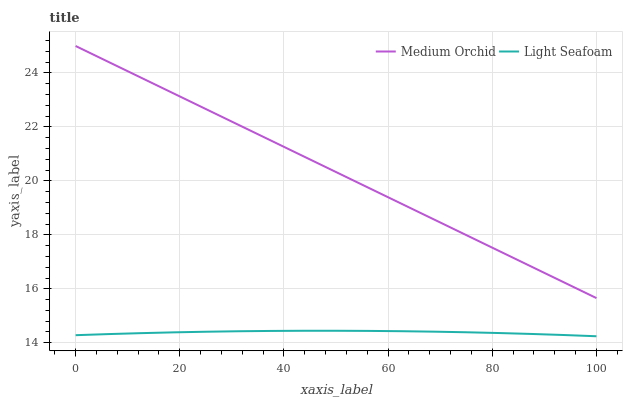Does Light Seafoam have the minimum area under the curve?
Answer yes or no. Yes. Does Medium Orchid have the maximum area under the curve?
Answer yes or no. Yes. Does Light Seafoam have the maximum area under the curve?
Answer yes or no. No. Is Medium Orchid the smoothest?
Answer yes or no. Yes. Is Light Seafoam the roughest?
Answer yes or no. Yes. Is Light Seafoam the smoothest?
Answer yes or no. No. Does Medium Orchid have the highest value?
Answer yes or no. Yes. Does Light Seafoam have the highest value?
Answer yes or no. No. Is Light Seafoam less than Medium Orchid?
Answer yes or no. Yes. Is Medium Orchid greater than Light Seafoam?
Answer yes or no. Yes. Does Light Seafoam intersect Medium Orchid?
Answer yes or no. No. 